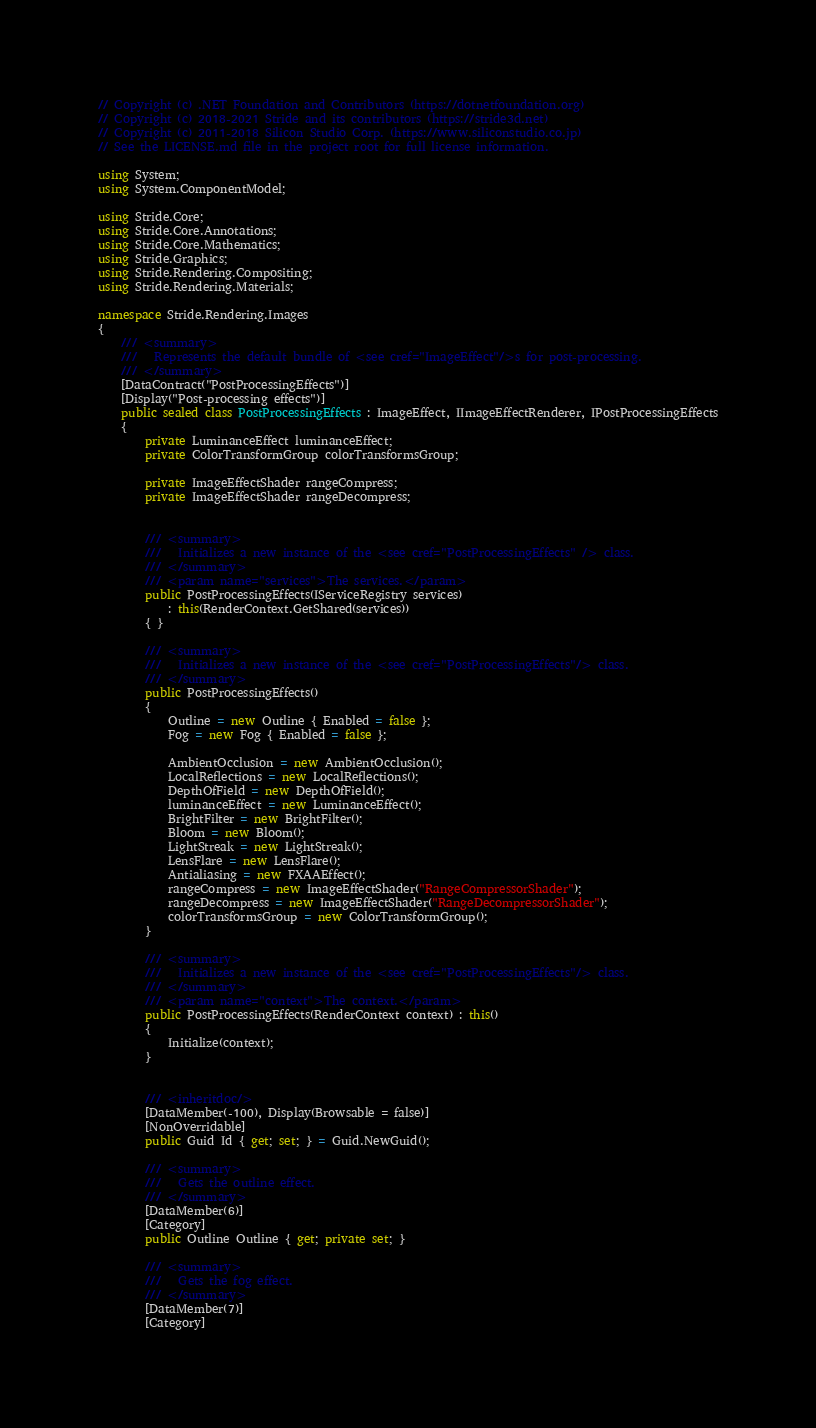Convert code to text. <code><loc_0><loc_0><loc_500><loc_500><_C#_>// Copyright (c) .NET Foundation and Contributors (https://dotnetfoundation.org)
// Copyright (c) 2018-2021 Stride and its contributors (https://stride3d.net)
// Copyright (c) 2011-2018 Silicon Studio Corp. (https://www.siliconstudio.co.jp)
// See the LICENSE.md file in the project root for full license information.

using System;
using System.ComponentModel;

using Stride.Core;
using Stride.Core.Annotations;
using Stride.Core.Mathematics;
using Stride.Graphics;
using Stride.Rendering.Compositing;
using Stride.Rendering.Materials;

namespace Stride.Rendering.Images
{
    /// <summary>
    ///   Represents the default bundle of <see cref="ImageEffect"/>s for post-processing.
    /// </summary>
    [DataContract("PostProcessingEffects")]
    [Display("Post-processing effects")]
    public sealed class PostProcessingEffects : ImageEffect, IImageEffectRenderer, IPostProcessingEffects
    {
        private LuminanceEffect luminanceEffect;
        private ColorTransformGroup colorTransformsGroup;

        private ImageEffectShader rangeCompress;
        private ImageEffectShader rangeDecompress;


        /// <summary>
        ///   Initializes a new instance of the <see cref="PostProcessingEffects" /> class.
        /// </summary>
        /// <param name="services">The services.</param>
        public PostProcessingEffects(IServiceRegistry services)
            : this(RenderContext.GetShared(services))
        { }

        /// <summary>
        ///   Initializes a new instance of the <see cref="PostProcessingEffects"/> class.
        /// </summary>
        public PostProcessingEffects()
        {
            Outline = new Outline { Enabled = false };
            Fog = new Fog { Enabled = false };

            AmbientOcclusion = new AmbientOcclusion();
            LocalReflections = new LocalReflections();
            DepthOfField = new DepthOfField();
            luminanceEffect = new LuminanceEffect();
            BrightFilter = new BrightFilter();
            Bloom = new Bloom();
            LightStreak = new LightStreak();
            LensFlare = new LensFlare();
            Antialiasing = new FXAAEffect();
            rangeCompress = new ImageEffectShader("RangeCompressorShader");
            rangeDecompress = new ImageEffectShader("RangeDecompressorShader");
            colorTransformsGroup = new ColorTransformGroup();
        }

        /// <summary>
        ///   Initializes a new instance of the <see cref="PostProcessingEffects"/> class.
        /// </summary>
        /// <param name="context">The context.</param>
        public PostProcessingEffects(RenderContext context) : this()
        {
            Initialize(context);
        }


        /// <inheritdoc/>
        [DataMember(-100), Display(Browsable = false)]
        [NonOverridable]
        public Guid Id { get; set; } = Guid.NewGuid();

        /// <summary>
        ///   Gets the outline effect.
        /// </summary>
        [DataMember(6)]
        [Category]
        public Outline Outline { get; private set; }

        /// <summary>
        ///   Gets the fog effect.
        /// </summary>
        [DataMember(7)]
        [Category]</code> 